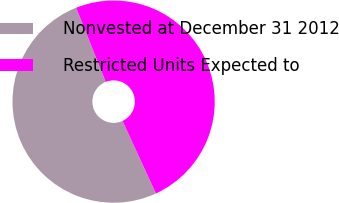Convert chart to OTSL. <chart><loc_0><loc_0><loc_500><loc_500><pie_chart><fcel>Nonvested at December 31 2012<fcel>Restricted Units Expected to<nl><fcel>50.82%<fcel>49.18%<nl></chart> 